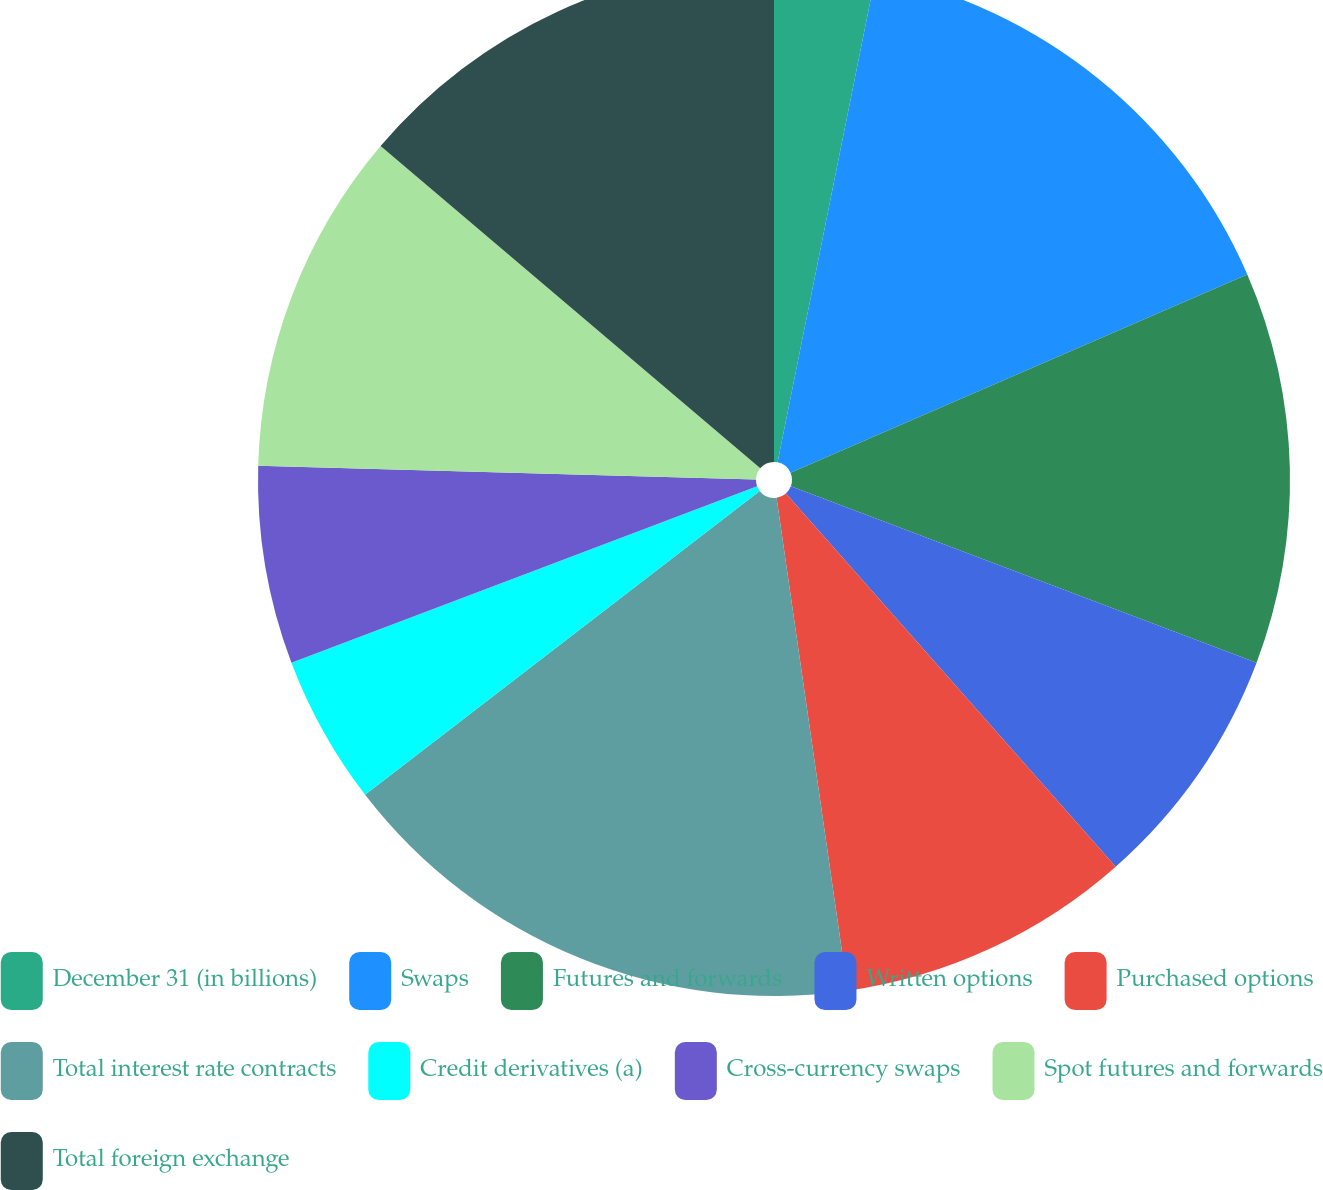Convert chart to OTSL. <chart><loc_0><loc_0><loc_500><loc_500><pie_chart><fcel>December 31 (in billions)<fcel>Swaps<fcel>Futures and forwards<fcel>Written options<fcel>Purchased options<fcel>Total interest rate contracts<fcel>Credit derivatives (a)<fcel>Cross-currency swaps<fcel>Spot futures and forwards<fcel>Total foreign exchange<nl><fcel>3.16%<fcel>15.32%<fcel>12.28%<fcel>7.72%<fcel>9.24%<fcel>16.84%<fcel>4.68%<fcel>6.2%<fcel>10.76%<fcel>13.8%<nl></chart> 